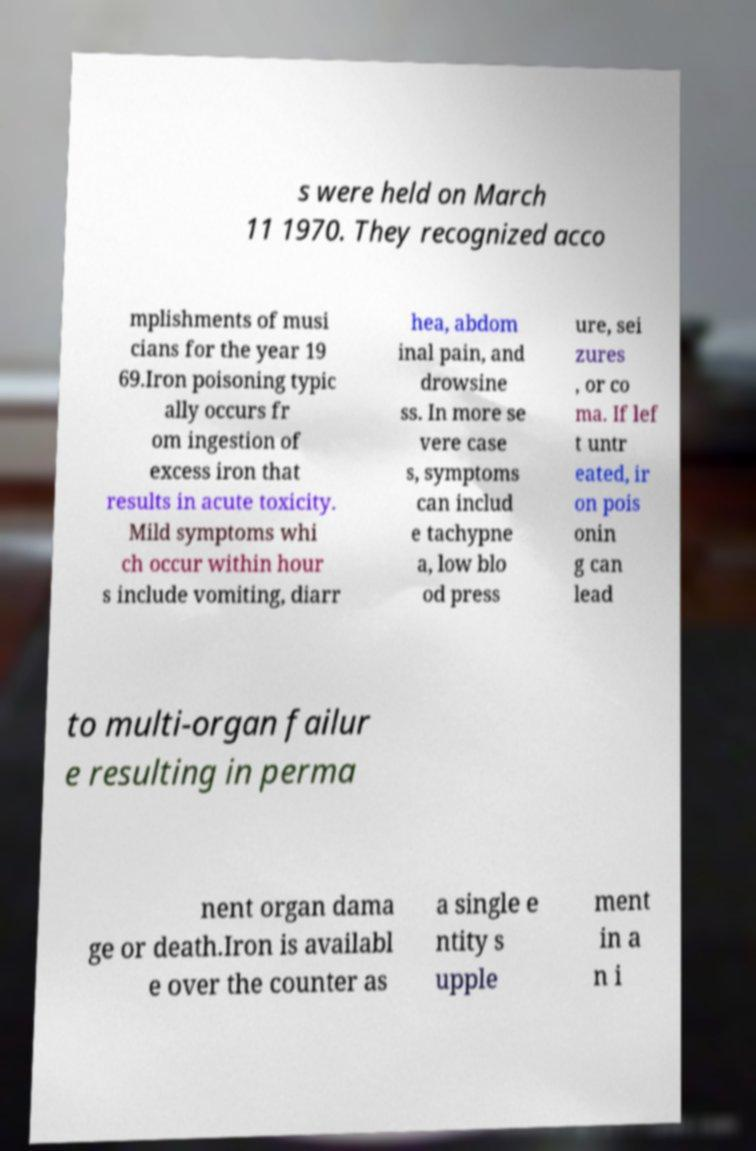What messages or text are displayed in this image? I need them in a readable, typed format. s were held on March 11 1970. They recognized acco mplishments of musi cians for the year 19 69.Iron poisoning typic ally occurs fr om ingestion of excess iron that results in acute toxicity. Mild symptoms whi ch occur within hour s include vomiting, diarr hea, abdom inal pain, and drowsine ss. In more se vere case s, symptoms can includ e tachypne a, low blo od press ure, sei zures , or co ma. If lef t untr eated, ir on pois onin g can lead to multi-organ failur e resulting in perma nent organ dama ge or death.Iron is availabl e over the counter as a single e ntity s upple ment in a n i 